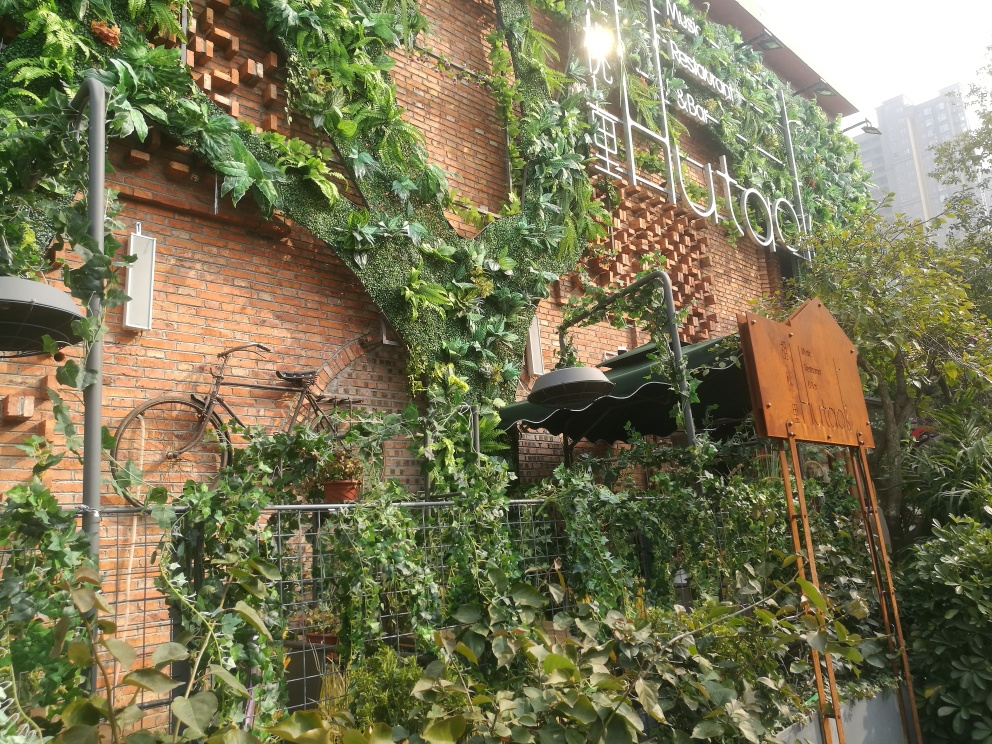What does the overall atmosphere of this place seem to be? The atmosphere is one that blends urban elements with nature, offering a serene and inviting space. The combination of the historical brick wall, lush greenery, and artistic touches like the bicycle suggest a warm, welcoming environment that values aesthetic harmony and tranquility. 